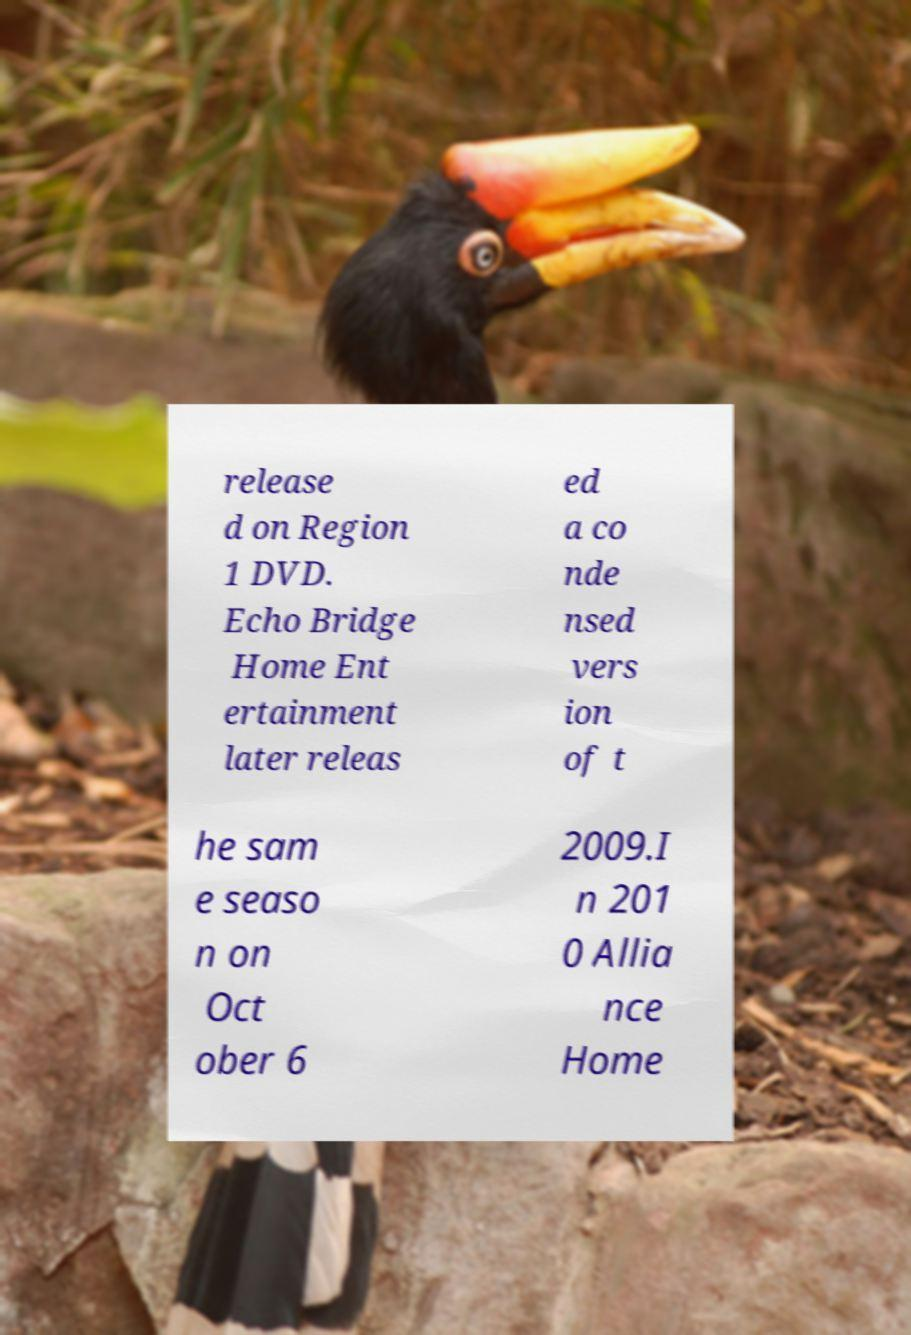Please identify and transcribe the text found in this image. release d on Region 1 DVD. Echo Bridge Home Ent ertainment later releas ed a co nde nsed vers ion of t he sam e seaso n on Oct ober 6 2009.I n 201 0 Allia nce Home 